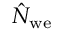<formula> <loc_0><loc_0><loc_500><loc_500>\hat { N } _ { w e }</formula> 